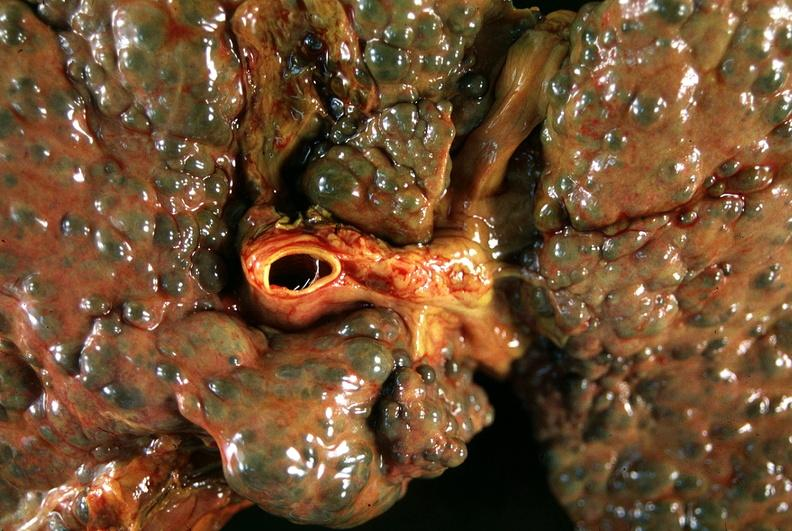s hepatobiliary present?
Answer the question using a single word or phrase. Yes 